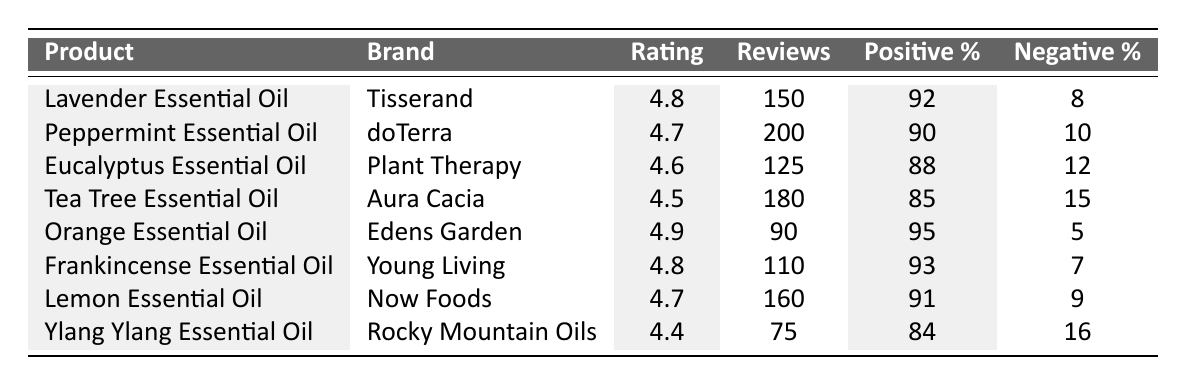What is the highest rating among the listed products? The table shows ratings for various essential oils. The highest rating is 4.9, which corresponds to the Orange Essential Oil by Edens Garden.
Answer: 4.9 Which product has the lowest positive feedback percentage? By examining the positive feedback percentages, Ylang Ylang Essential Oil has the lowest percentage at 84%.
Answer: 84% How many reviews did the Tea Tree Essential Oil receive? The table indicates that Tea Tree Essential Oil received a total of 180 reviews.
Answer: 180 What is the average rating of all the essential oils listed? To find the average rating, sum all ratings (4.8 + 4.7 + 4.6 + 4.5 + 4.9 + 4.8 + 4.7 + 4.4) = 36.4, then divide by the number of products (8), which gives an average of 36.4/8 = 4.55.
Answer: 4.55 Is the negative feedback percentage for any product greater than 15%? The table shows negative feedback percentages, and Ylang Ylang Essential Oil has a percentage of 16%, which is greater than 15%.
Answer: Yes Which product had the highest number of reviews, and what was that number? From the table, Peppermint Essential Oil has the highest number of reviews at 200.
Answer: Peppermint Essential Oil, 200 What is the difference in positive feedback percentage between Lavender Essential Oil and Eucalyptus Essential Oil? Lavender Essential Oil has a positive feedback percentage of 92%, and Eucalyptus Essential Oil has 88%. The difference is 92 - 88 = 4%.
Answer: 4% How many essential oils have a rating of 4.7 or higher? The ratings for each oil show that there are 6 products (Lavender, Peppermint, Orange, Frankincense, Lemon, and Tea Tree) with ratings of 4.7 or higher.
Answer: 6 Which brand has the product with the least number of reviews? Looking at the reviews, Ylang Ylang Essential Oil by Rocky Mountain Oils has the least number of reviews at 75.
Answer: Rocky Mountain Oils What percentage of positive feedback does the Frankincense Essential Oil have? The table lists Frankincense Essential Oil with a positive feedback percentage of 93%.
Answer: 93% 